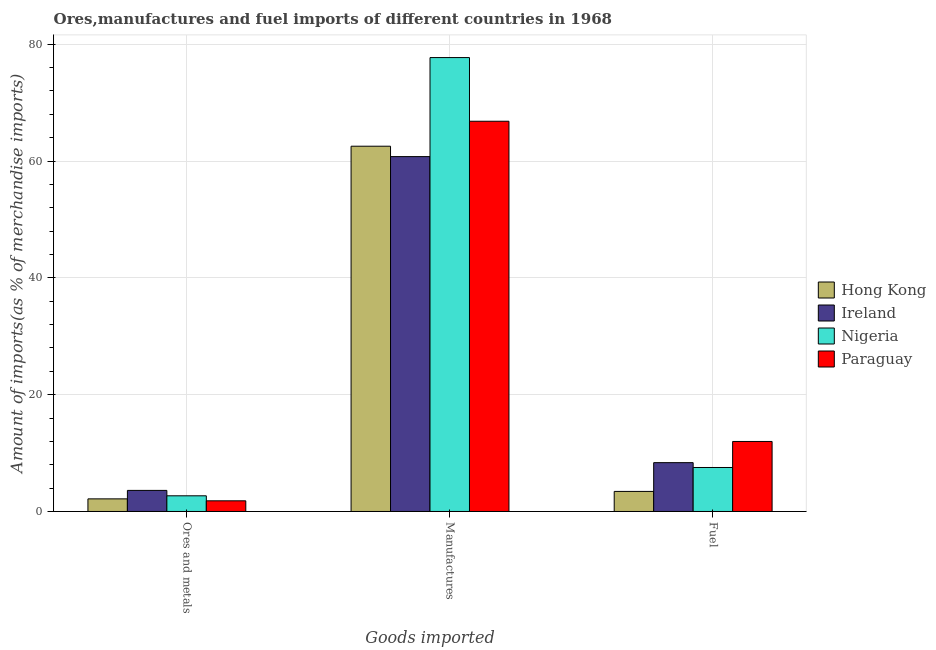How many groups of bars are there?
Ensure brevity in your answer.  3. Are the number of bars on each tick of the X-axis equal?
Provide a short and direct response. Yes. How many bars are there on the 3rd tick from the right?
Offer a terse response. 4. What is the label of the 3rd group of bars from the left?
Provide a succinct answer. Fuel. What is the percentage of ores and metals imports in Hong Kong?
Ensure brevity in your answer.  2.16. Across all countries, what is the maximum percentage of manufactures imports?
Provide a succinct answer. 77.72. Across all countries, what is the minimum percentage of ores and metals imports?
Provide a succinct answer. 1.82. In which country was the percentage of fuel imports maximum?
Provide a succinct answer. Paraguay. In which country was the percentage of fuel imports minimum?
Keep it short and to the point. Hong Kong. What is the total percentage of fuel imports in the graph?
Provide a short and direct response. 31.32. What is the difference between the percentage of fuel imports in Hong Kong and that in Paraguay?
Ensure brevity in your answer.  -8.55. What is the difference between the percentage of manufactures imports in Hong Kong and the percentage of fuel imports in Ireland?
Your response must be concise. 54.18. What is the average percentage of fuel imports per country?
Keep it short and to the point. 7.83. What is the difference between the percentage of fuel imports and percentage of ores and metals imports in Paraguay?
Offer a very short reply. 10.17. What is the ratio of the percentage of manufactures imports in Ireland to that in Hong Kong?
Offer a very short reply. 0.97. Is the percentage of fuel imports in Paraguay less than that in Nigeria?
Your answer should be very brief. No. Is the difference between the percentage of ores and metals imports in Hong Kong and Paraguay greater than the difference between the percentage of manufactures imports in Hong Kong and Paraguay?
Your answer should be compact. Yes. What is the difference between the highest and the second highest percentage of ores and metals imports?
Provide a short and direct response. 0.92. What is the difference between the highest and the lowest percentage of manufactures imports?
Your answer should be compact. 16.95. In how many countries, is the percentage of fuel imports greater than the average percentage of fuel imports taken over all countries?
Provide a short and direct response. 2. What does the 3rd bar from the left in Manufactures represents?
Keep it short and to the point. Nigeria. What does the 4th bar from the right in Manufactures represents?
Your answer should be compact. Hong Kong. How many countries are there in the graph?
Your answer should be very brief. 4. Does the graph contain any zero values?
Provide a succinct answer. No. Does the graph contain grids?
Offer a terse response. Yes. Where does the legend appear in the graph?
Offer a very short reply. Center right. What is the title of the graph?
Your answer should be compact. Ores,manufactures and fuel imports of different countries in 1968. What is the label or title of the X-axis?
Give a very brief answer. Goods imported. What is the label or title of the Y-axis?
Give a very brief answer. Amount of imports(as % of merchandise imports). What is the Amount of imports(as % of merchandise imports) of Hong Kong in Ores and metals?
Your answer should be very brief. 2.16. What is the Amount of imports(as % of merchandise imports) in Ireland in Ores and metals?
Offer a very short reply. 3.61. What is the Amount of imports(as % of merchandise imports) in Nigeria in Ores and metals?
Provide a short and direct response. 2.69. What is the Amount of imports(as % of merchandise imports) of Paraguay in Ores and metals?
Provide a succinct answer. 1.82. What is the Amount of imports(as % of merchandise imports) of Hong Kong in Manufactures?
Provide a succinct answer. 62.54. What is the Amount of imports(as % of merchandise imports) in Ireland in Manufactures?
Provide a succinct answer. 60.76. What is the Amount of imports(as % of merchandise imports) in Nigeria in Manufactures?
Make the answer very short. 77.72. What is the Amount of imports(as % of merchandise imports) in Paraguay in Manufactures?
Your answer should be very brief. 66.82. What is the Amount of imports(as % of merchandise imports) of Hong Kong in Fuel?
Provide a short and direct response. 3.44. What is the Amount of imports(as % of merchandise imports) in Ireland in Fuel?
Offer a terse response. 8.36. What is the Amount of imports(as % of merchandise imports) of Nigeria in Fuel?
Your answer should be compact. 7.53. What is the Amount of imports(as % of merchandise imports) in Paraguay in Fuel?
Provide a succinct answer. 11.99. Across all Goods imported, what is the maximum Amount of imports(as % of merchandise imports) of Hong Kong?
Offer a terse response. 62.54. Across all Goods imported, what is the maximum Amount of imports(as % of merchandise imports) of Ireland?
Provide a succinct answer. 60.76. Across all Goods imported, what is the maximum Amount of imports(as % of merchandise imports) in Nigeria?
Offer a terse response. 77.72. Across all Goods imported, what is the maximum Amount of imports(as % of merchandise imports) of Paraguay?
Your response must be concise. 66.82. Across all Goods imported, what is the minimum Amount of imports(as % of merchandise imports) in Hong Kong?
Keep it short and to the point. 2.16. Across all Goods imported, what is the minimum Amount of imports(as % of merchandise imports) of Ireland?
Your response must be concise. 3.61. Across all Goods imported, what is the minimum Amount of imports(as % of merchandise imports) in Nigeria?
Provide a short and direct response. 2.69. Across all Goods imported, what is the minimum Amount of imports(as % of merchandise imports) of Paraguay?
Offer a terse response. 1.82. What is the total Amount of imports(as % of merchandise imports) in Hong Kong in the graph?
Give a very brief answer. 68.14. What is the total Amount of imports(as % of merchandise imports) in Ireland in the graph?
Provide a succinct answer. 72.73. What is the total Amount of imports(as % of merchandise imports) of Nigeria in the graph?
Make the answer very short. 87.93. What is the total Amount of imports(as % of merchandise imports) of Paraguay in the graph?
Keep it short and to the point. 80.63. What is the difference between the Amount of imports(as % of merchandise imports) of Hong Kong in Ores and metals and that in Manufactures?
Offer a very short reply. -60.38. What is the difference between the Amount of imports(as % of merchandise imports) in Ireland in Ores and metals and that in Manufactures?
Your response must be concise. -57.15. What is the difference between the Amount of imports(as % of merchandise imports) in Nigeria in Ores and metals and that in Manufactures?
Provide a succinct answer. -75.03. What is the difference between the Amount of imports(as % of merchandise imports) of Paraguay in Ores and metals and that in Manufactures?
Provide a short and direct response. -64.99. What is the difference between the Amount of imports(as % of merchandise imports) of Hong Kong in Ores and metals and that in Fuel?
Provide a succinct answer. -1.28. What is the difference between the Amount of imports(as % of merchandise imports) of Ireland in Ores and metals and that in Fuel?
Your answer should be compact. -4.75. What is the difference between the Amount of imports(as % of merchandise imports) of Nigeria in Ores and metals and that in Fuel?
Make the answer very short. -4.85. What is the difference between the Amount of imports(as % of merchandise imports) in Paraguay in Ores and metals and that in Fuel?
Ensure brevity in your answer.  -10.16. What is the difference between the Amount of imports(as % of merchandise imports) in Hong Kong in Manufactures and that in Fuel?
Give a very brief answer. 59.11. What is the difference between the Amount of imports(as % of merchandise imports) in Ireland in Manufactures and that in Fuel?
Your response must be concise. 52.4. What is the difference between the Amount of imports(as % of merchandise imports) in Nigeria in Manufactures and that in Fuel?
Your answer should be very brief. 70.18. What is the difference between the Amount of imports(as % of merchandise imports) of Paraguay in Manufactures and that in Fuel?
Provide a succinct answer. 54.83. What is the difference between the Amount of imports(as % of merchandise imports) in Hong Kong in Ores and metals and the Amount of imports(as % of merchandise imports) in Ireland in Manufactures?
Your answer should be compact. -58.6. What is the difference between the Amount of imports(as % of merchandise imports) of Hong Kong in Ores and metals and the Amount of imports(as % of merchandise imports) of Nigeria in Manufactures?
Your response must be concise. -75.56. What is the difference between the Amount of imports(as % of merchandise imports) in Hong Kong in Ores and metals and the Amount of imports(as % of merchandise imports) in Paraguay in Manufactures?
Your response must be concise. -64.66. What is the difference between the Amount of imports(as % of merchandise imports) of Ireland in Ores and metals and the Amount of imports(as % of merchandise imports) of Nigeria in Manufactures?
Your answer should be very brief. -74.11. What is the difference between the Amount of imports(as % of merchandise imports) in Ireland in Ores and metals and the Amount of imports(as % of merchandise imports) in Paraguay in Manufactures?
Keep it short and to the point. -63.21. What is the difference between the Amount of imports(as % of merchandise imports) in Nigeria in Ores and metals and the Amount of imports(as % of merchandise imports) in Paraguay in Manufactures?
Give a very brief answer. -64.13. What is the difference between the Amount of imports(as % of merchandise imports) of Hong Kong in Ores and metals and the Amount of imports(as % of merchandise imports) of Ireland in Fuel?
Your response must be concise. -6.2. What is the difference between the Amount of imports(as % of merchandise imports) in Hong Kong in Ores and metals and the Amount of imports(as % of merchandise imports) in Nigeria in Fuel?
Offer a terse response. -5.37. What is the difference between the Amount of imports(as % of merchandise imports) in Hong Kong in Ores and metals and the Amount of imports(as % of merchandise imports) in Paraguay in Fuel?
Give a very brief answer. -9.83. What is the difference between the Amount of imports(as % of merchandise imports) in Ireland in Ores and metals and the Amount of imports(as % of merchandise imports) in Nigeria in Fuel?
Give a very brief answer. -3.92. What is the difference between the Amount of imports(as % of merchandise imports) of Ireland in Ores and metals and the Amount of imports(as % of merchandise imports) of Paraguay in Fuel?
Make the answer very short. -8.38. What is the difference between the Amount of imports(as % of merchandise imports) of Nigeria in Ores and metals and the Amount of imports(as % of merchandise imports) of Paraguay in Fuel?
Give a very brief answer. -9.3. What is the difference between the Amount of imports(as % of merchandise imports) in Hong Kong in Manufactures and the Amount of imports(as % of merchandise imports) in Ireland in Fuel?
Your answer should be compact. 54.18. What is the difference between the Amount of imports(as % of merchandise imports) of Hong Kong in Manufactures and the Amount of imports(as % of merchandise imports) of Nigeria in Fuel?
Provide a succinct answer. 55.01. What is the difference between the Amount of imports(as % of merchandise imports) in Hong Kong in Manufactures and the Amount of imports(as % of merchandise imports) in Paraguay in Fuel?
Give a very brief answer. 50.55. What is the difference between the Amount of imports(as % of merchandise imports) in Ireland in Manufactures and the Amount of imports(as % of merchandise imports) in Nigeria in Fuel?
Provide a short and direct response. 53.23. What is the difference between the Amount of imports(as % of merchandise imports) of Ireland in Manufactures and the Amount of imports(as % of merchandise imports) of Paraguay in Fuel?
Your response must be concise. 48.77. What is the difference between the Amount of imports(as % of merchandise imports) in Nigeria in Manufactures and the Amount of imports(as % of merchandise imports) in Paraguay in Fuel?
Provide a succinct answer. 65.73. What is the average Amount of imports(as % of merchandise imports) in Hong Kong per Goods imported?
Give a very brief answer. 22.71. What is the average Amount of imports(as % of merchandise imports) of Ireland per Goods imported?
Make the answer very short. 24.24. What is the average Amount of imports(as % of merchandise imports) in Nigeria per Goods imported?
Make the answer very short. 29.31. What is the average Amount of imports(as % of merchandise imports) of Paraguay per Goods imported?
Your answer should be very brief. 26.88. What is the difference between the Amount of imports(as % of merchandise imports) of Hong Kong and Amount of imports(as % of merchandise imports) of Ireland in Ores and metals?
Your answer should be very brief. -1.45. What is the difference between the Amount of imports(as % of merchandise imports) of Hong Kong and Amount of imports(as % of merchandise imports) of Nigeria in Ores and metals?
Your answer should be compact. -0.53. What is the difference between the Amount of imports(as % of merchandise imports) in Hong Kong and Amount of imports(as % of merchandise imports) in Paraguay in Ores and metals?
Give a very brief answer. 0.34. What is the difference between the Amount of imports(as % of merchandise imports) in Ireland and Amount of imports(as % of merchandise imports) in Nigeria in Ores and metals?
Make the answer very short. 0.92. What is the difference between the Amount of imports(as % of merchandise imports) of Ireland and Amount of imports(as % of merchandise imports) of Paraguay in Ores and metals?
Your response must be concise. 1.78. What is the difference between the Amount of imports(as % of merchandise imports) of Nigeria and Amount of imports(as % of merchandise imports) of Paraguay in Ores and metals?
Make the answer very short. 0.86. What is the difference between the Amount of imports(as % of merchandise imports) of Hong Kong and Amount of imports(as % of merchandise imports) of Ireland in Manufactures?
Offer a terse response. 1.78. What is the difference between the Amount of imports(as % of merchandise imports) in Hong Kong and Amount of imports(as % of merchandise imports) in Nigeria in Manufactures?
Make the answer very short. -15.18. What is the difference between the Amount of imports(as % of merchandise imports) in Hong Kong and Amount of imports(as % of merchandise imports) in Paraguay in Manufactures?
Make the answer very short. -4.27. What is the difference between the Amount of imports(as % of merchandise imports) of Ireland and Amount of imports(as % of merchandise imports) of Nigeria in Manufactures?
Provide a short and direct response. -16.95. What is the difference between the Amount of imports(as % of merchandise imports) of Ireland and Amount of imports(as % of merchandise imports) of Paraguay in Manufactures?
Provide a short and direct response. -6.05. What is the difference between the Amount of imports(as % of merchandise imports) in Nigeria and Amount of imports(as % of merchandise imports) in Paraguay in Manufactures?
Give a very brief answer. 10.9. What is the difference between the Amount of imports(as % of merchandise imports) of Hong Kong and Amount of imports(as % of merchandise imports) of Ireland in Fuel?
Provide a short and direct response. -4.93. What is the difference between the Amount of imports(as % of merchandise imports) in Hong Kong and Amount of imports(as % of merchandise imports) in Nigeria in Fuel?
Ensure brevity in your answer.  -4.1. What is the difference between the Amount of imports(as % of merchandise imports) of Hong Kong and Amount of imports(as % of merchandise imports) of Paraguay in Fuel?
Your answer should be very brief. -8.55. What is the difference between the Amount of imports(as % of merchandise imports) in Ireland and Amount of imports(as % of merchandise imports) in Nigeria in Fuel?
Offer a very short reply. 0.83. What is the difference between the Amount of imports(as % of merchandise imports) of Ireland and Amount of imports(as % of merchandise imports) of Paraguay in Fuel?
Make the answer very short. -3.63. What is the difference between the Amount of imports(as % of merchandise imports) of Nigeria and Amount of imports(as % of merchandise imports) of Paraguay in Fuel?
Provide a short and direct response. -4.46. What is the ratio of the Amount of imports(as % of merchandise imports) of Hong Kong in Ores and metals to that in Manufactures?
Make the answer very short. 0.03. What is the ratio of the Amount of imports(as % of merchandise imports) in Ireland in Ores and metals to that in Manufactures?
Provide a succinct answer. 0.06. What is the ratio of the Amount of imports(as % of merchandise imports) of Nigeria in Ores and metals to that in Manufactures?
Ensure brevity in your answer.  0.03. What is the ratio of the Amount of imports(as % of merchandise imports) in Paraguay in Ores and metals to that in Manufactures?
Your response must be concise. 0.03. What is the ratio of the Amount of imports(as % of merchandise imports) in Hong Kong in Ores and metals to that in Fuel?
Keep it short and to the point. 0.63. What is the ratio of the Amount of imports(as % of merchandise imports) of Ireland in Ores and metals to that in Fuel?
Your answer should be very brief. 0.43. What is the ratio of the Amount of imports(as % of merchandise imports) of Nigeria in Ores and metals to that in Fuel?
Keep it short and to the point. 0.36. What is the ratio of the Amount of imports(as % of merchandise imports) in Paraguay in Ores and metals to that in Fuel?
Offer a terse response. 0.15. What is the ratio of the Amount of imports(as % of merchandise imports) in Hong Kong in Manufactures to that in Fuel?
Provide a short and direct response. 18.2. What is the ratio of the Amount of imports(as % of merchandise imports) of Ireland in Manufactures to that in Fuel?
Keep it short and to the point. 7.27. What is the ratio of the Amount of imports(as % of merchandise imports) of Nigeria in Manufactures to that in Fuel?
Your response must be concise. 10.32. What is the ratio of the Amount of imports(as % of merchandise imports) in Paraguay in Manufactures to that in Fuel?
Provide a succinct answer. 5.57. What is the difference between the highest and the second highest Amount of imports(as % of merchandise imports) in Hong Kong?
Your response must be concise. 59.11. What is the difference between the highest and the second highest Amount of imports(as % of merchandise imports) of Ireland?
Your answer should be compact. 52.4. What is the difference between the highest and the second highest Amount of imports(as % of merchandise imports) in Nigeria?
Your answer should be compact. 70.18. What is the difference between the highest and the second highest Amount of imports(as % of merchandise imports) in Paraguay?
Offer a terse response. 54.83. What is the difference between the highest and the lowest Amount of imports(as % of merchandise imports) in Hong Kong?
Make the answer very short. 60.38. What is the difference between the highest and the lowest Amount of imports(as % of merchandise imports) in Ireland?
Offer a very short reply. 57.15. What is the difference between the highest and the lowest Amount of imports(as % of merchandise imports) of Nigeria?
Offer a very short reply. 75.03. What is the difference between the highest and the lowest Amount of imports(as % of merchandise imports) in Paraguay?
Your response must be concise. 64.99. 